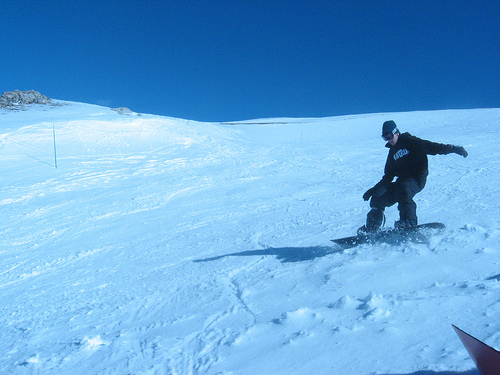<image>
Is the man behind the snow? No. The man is not behind the snow. From this viewpoint, the man appears to be positioned elsewhere in the scene. 